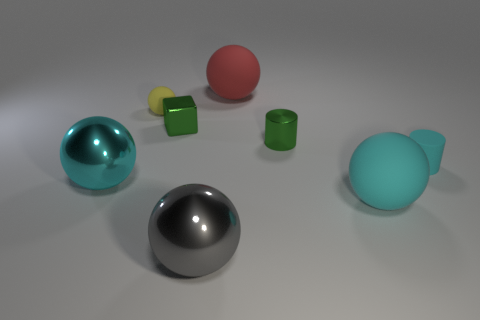Add 2 blocks. How many objects exist? 10 Subtract 0 yellow cubes. How many objects are left? 8 Subtract all cylinders. How many objects are left? 6 Subtract 1 balls. How many balls are left? 4 Subtract all gray cubes. Subtract all green balls. How many cubes are left? 1 Subtract all red cubes. How many red spheres are left? 1 Subtract all tiny cubes. Subtract all cyan matte cylinders. How many objects are left? 6 Add 6 big cyan things. How many big cyan things are left? 8 Add 6 green cylinders. How many green cylinders exist? 7 Subtract all red balls. How many balls are left? 4 